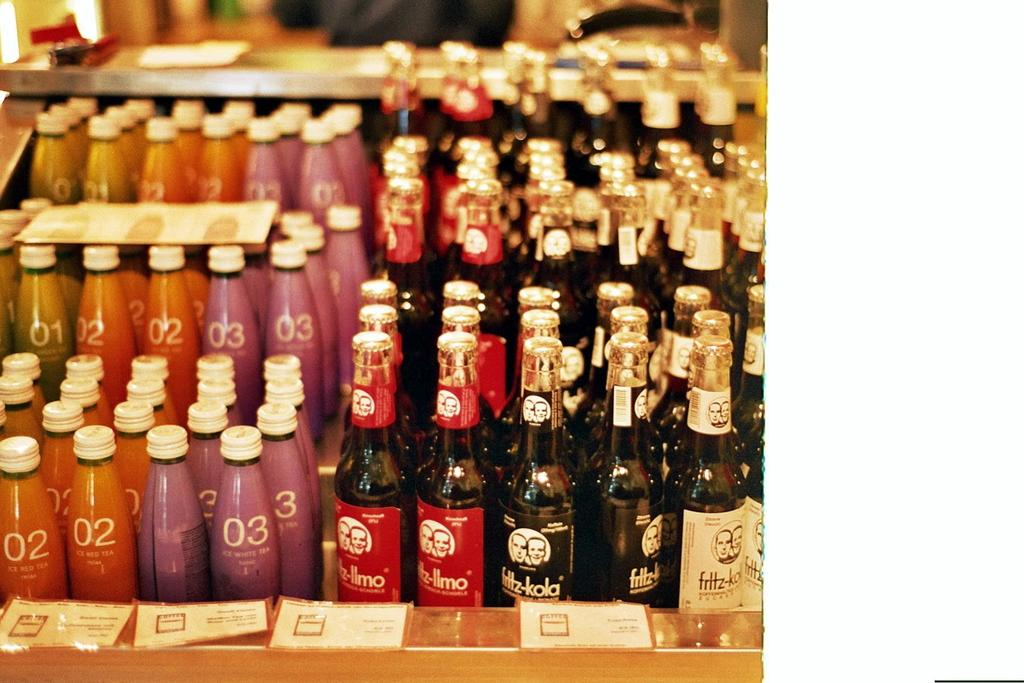<image>
Provide a brief description of the given image. A large display of bottled beverages including many of the Fritz-kola brand. 